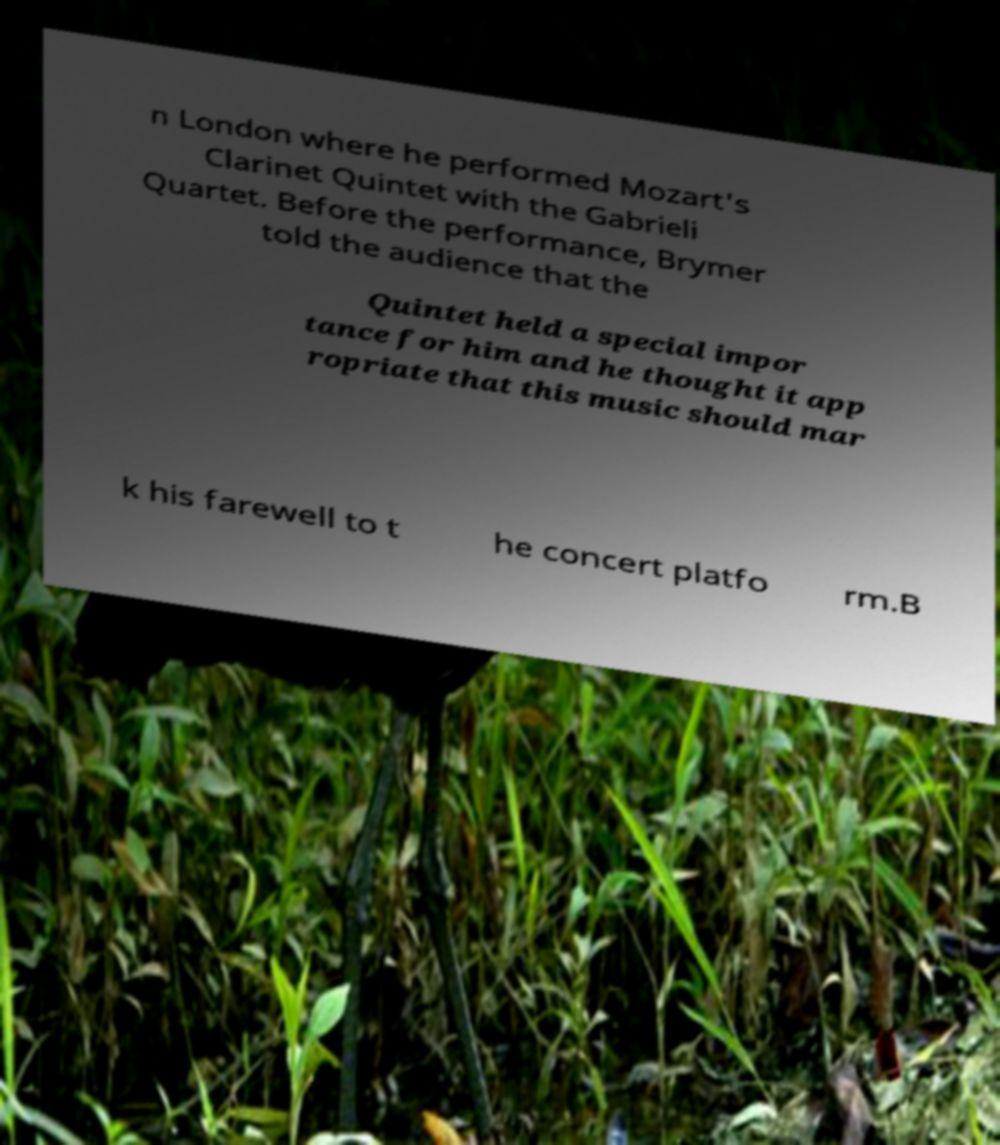There's text embedded in this image that I need extracted. Can you transcribe it verbatim? n London where he performed Mozart's Clarinet Quintet with the Gabrieli Quartet. Before the performance, Brymer told the audience that the Quintet held a special impor tance for him and he thought it app ropriate that this music should mar k his farewell to t he concert platfo rm.B 